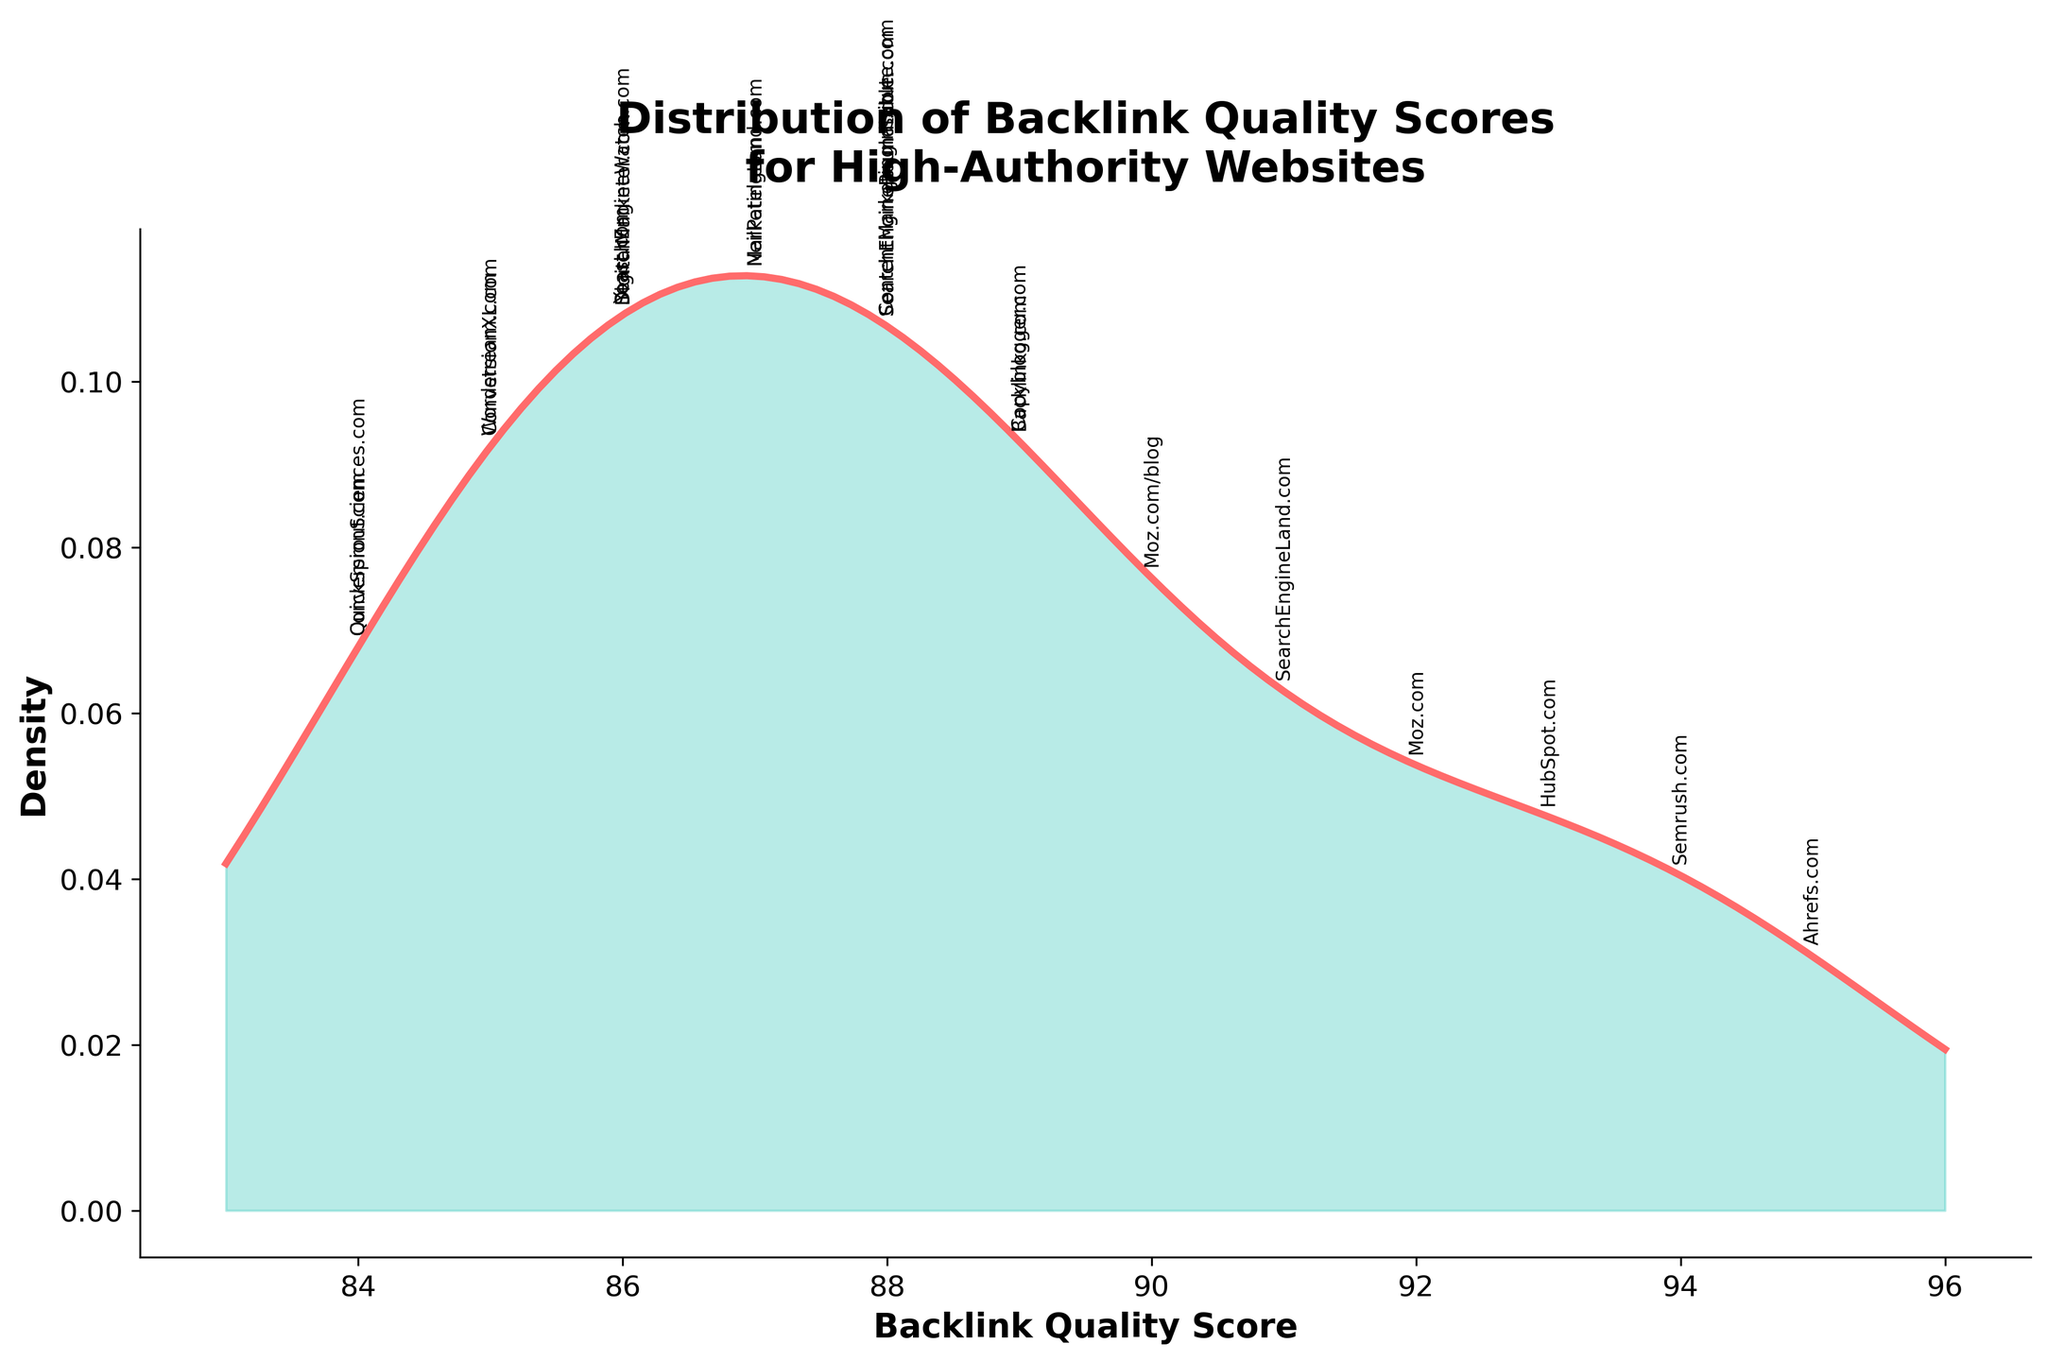What is the title of the figure? The title of the figure is located at the top and provides an overview of what the figure represents. By looking at the title, we understand the main focus of the data visualization.
Answer: Distribution of Backlink Quality Scores for High-Authority Websites How many data points are represented in the plot? Each website's backlink quality score is annotated within the density plot. By counting these annotations, we can determine the total number of data points.
Answer: 20 What is the range of backlink quality scores in the figure? To find the range, look at the horizontal axis labeled 'Backlink Quality Score' and identify the minimum and maximum values. The scores range from the lowest value to the highest value shown.
Answer: 84 to 95 Which website has the highest backlink quality score? By looking at the annotations for the data points on the plot, we can identify the website with the highest value. This is the point furthest to the right on the x-axis.
Answer: Ahrefs.com What is the median backlink quality score in the figure? To find the median score, you need to order all backlink quality scores from lowest to highest and identify the middle value. For 20 data points, the median is the average of the 10th and 11th values in the ordered list.
Answer: 87.5 Are there more websites with a backlink quality score above 90 or below 90? By comparing the number of websites annotated with scores above 90 against those with scores below 90, we can determine which side has more data points.
Answer: Below 90 What is the backlink quality score of HubSpot.com? Locate the annotation for HubSpot.com on the plot to find its associated backlink quality score.
Answer: 93 Which website has the closest backlink quality score to the median value? First, identify the median value, then look for the website whose score is closest to this value. Cross-reference the annotations and scores to find the closest match.
Answer: NeilPatel.com Which website has a backlink quality score that matches the highest peak of the density? Find the highest peak in the density curve and look for any scores directly annotated at this peak value. This indicates that particular score aligns with the highest density of data points.
Answer: Multiple websites, including QuickSprout.com and ConversionSciences.com Is the data distribution skewed more towards higher or lower backlink quality scores? Analyze the shape of the density curve by observing if it tails more towards the higher end (right) or the lower end (left) of the score scale. This indicates the skewness of the distribution.
Answer: Lower scores (left-skewed) 